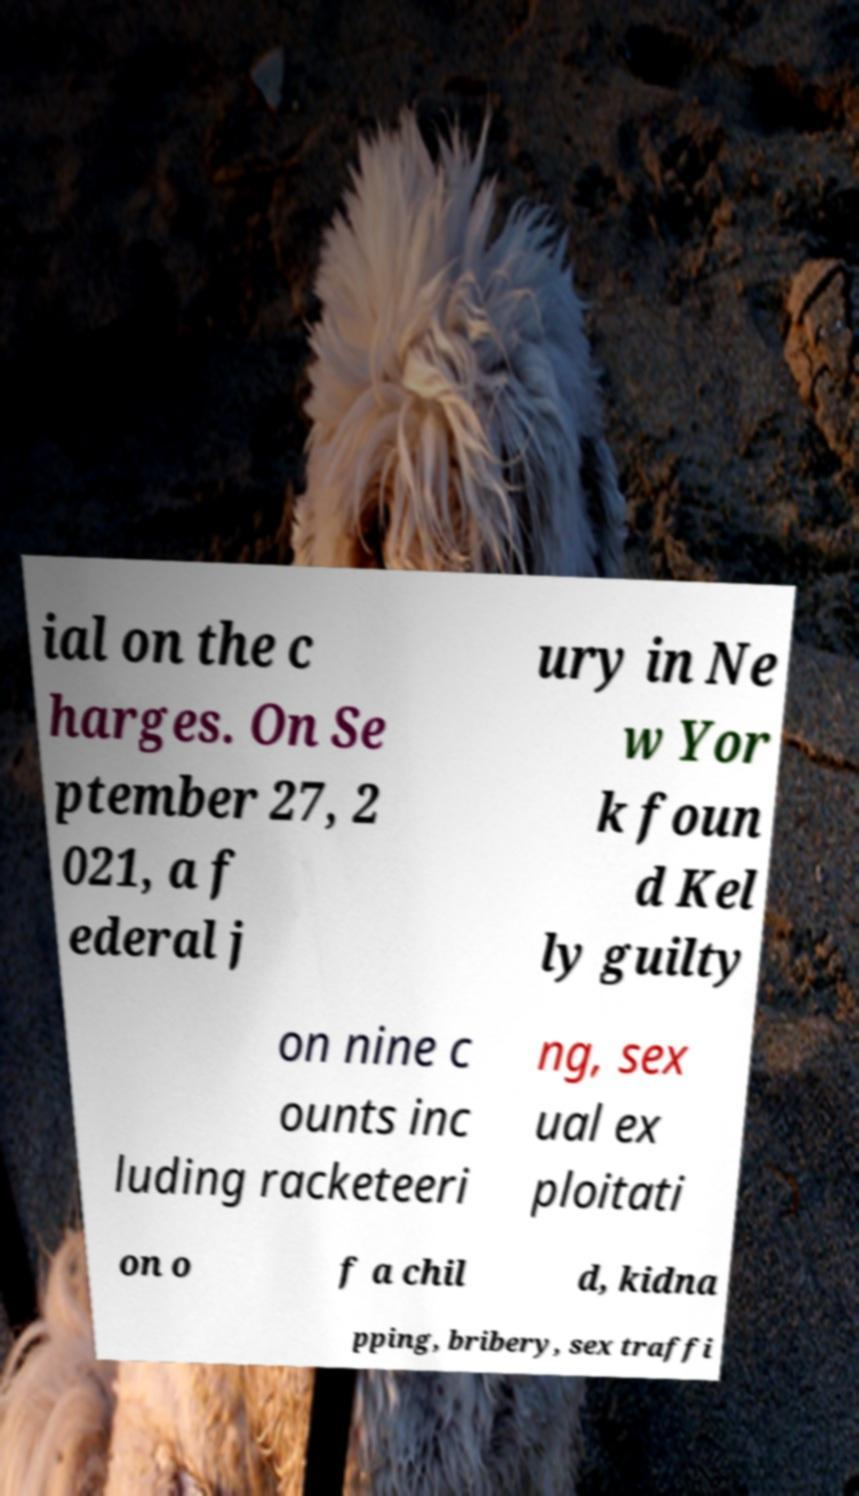Please read and relay the text visible in this image. What does it say? ial on the c harges. On Se ptember 27, 2 021, a f ederal j ury in Ne w Yor k foun d Kel ly guilty on nine c ounts inc luding racketeeri ng, sex ual ex ploitati on o f a chil d, kidna pping, bribery, sex traffi 